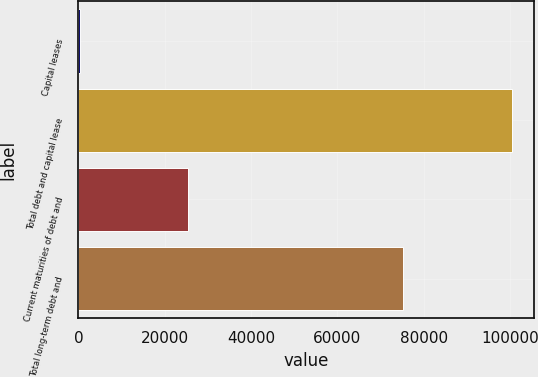Convert chart to OTSL. <chart><loc_0><loc_0><loc_500><loc_500><bar_chart><fcel>Capital leases<fcel>Total debt and capital lease<fcel>Current maturities of debt and<fcel>Total long-term debt and<nl><fcel>469<fcel>100469<fcel>25320<fcel>75149<nl></chart> 